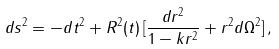<formula> <loc_0><loc_0><loc_500><loc_500>d s ^ { 2 } = - d t ^ { 2 } + R ^ { 2 } ( t ) \, [ \frac { d r ^ { 2 } } { 1 - k r ^ { 2 } } + r ^ { 2 } d \Omega ^ { 2 } ] \, ,</formula> 